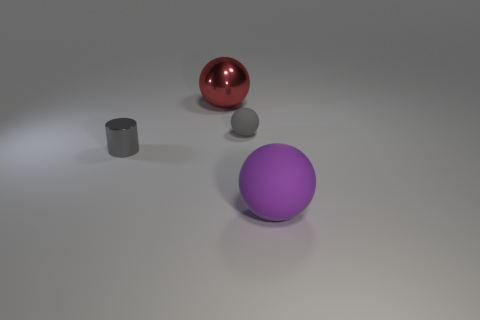What number of objects are small things that are left of the tiny gray rubber object or spheres?
Offer a terse response. 4. The thing that is the same color as the small rubber ball is what shape?
Offer a terse response. Cylinder. What is the material of the gray object right of the ball that is on the left side of the gray rubber thing?
Give a very brief answer. Rubber. Is there a purple ball made of the same material as the gray cylinder?
Your answer should be compact. No. There is a gray thing right of the small gray shiny cylinder; is there a gray ball that is on the left side of it?
Provide a succinct answer. No. There is a large sphere that is in front of the red sphere; what is it made of?
Provide a short and direct response. Rubber. Does the gray metallic object have the same shape as the large purple object?
Provide a succinct answer. No. What is the color of the matte sphere in front of the matte object behind the tiny object on the left side of the big shiny sphere?
Your answer should be compact. Purple. How many other objects have the same shape as the tiny metal object?
Provide a short and direct response. 0. There is a object that is behind the gray thing that is on the right side of the big red shiny thing; how big is it?
Offer a very short reply. Large. 